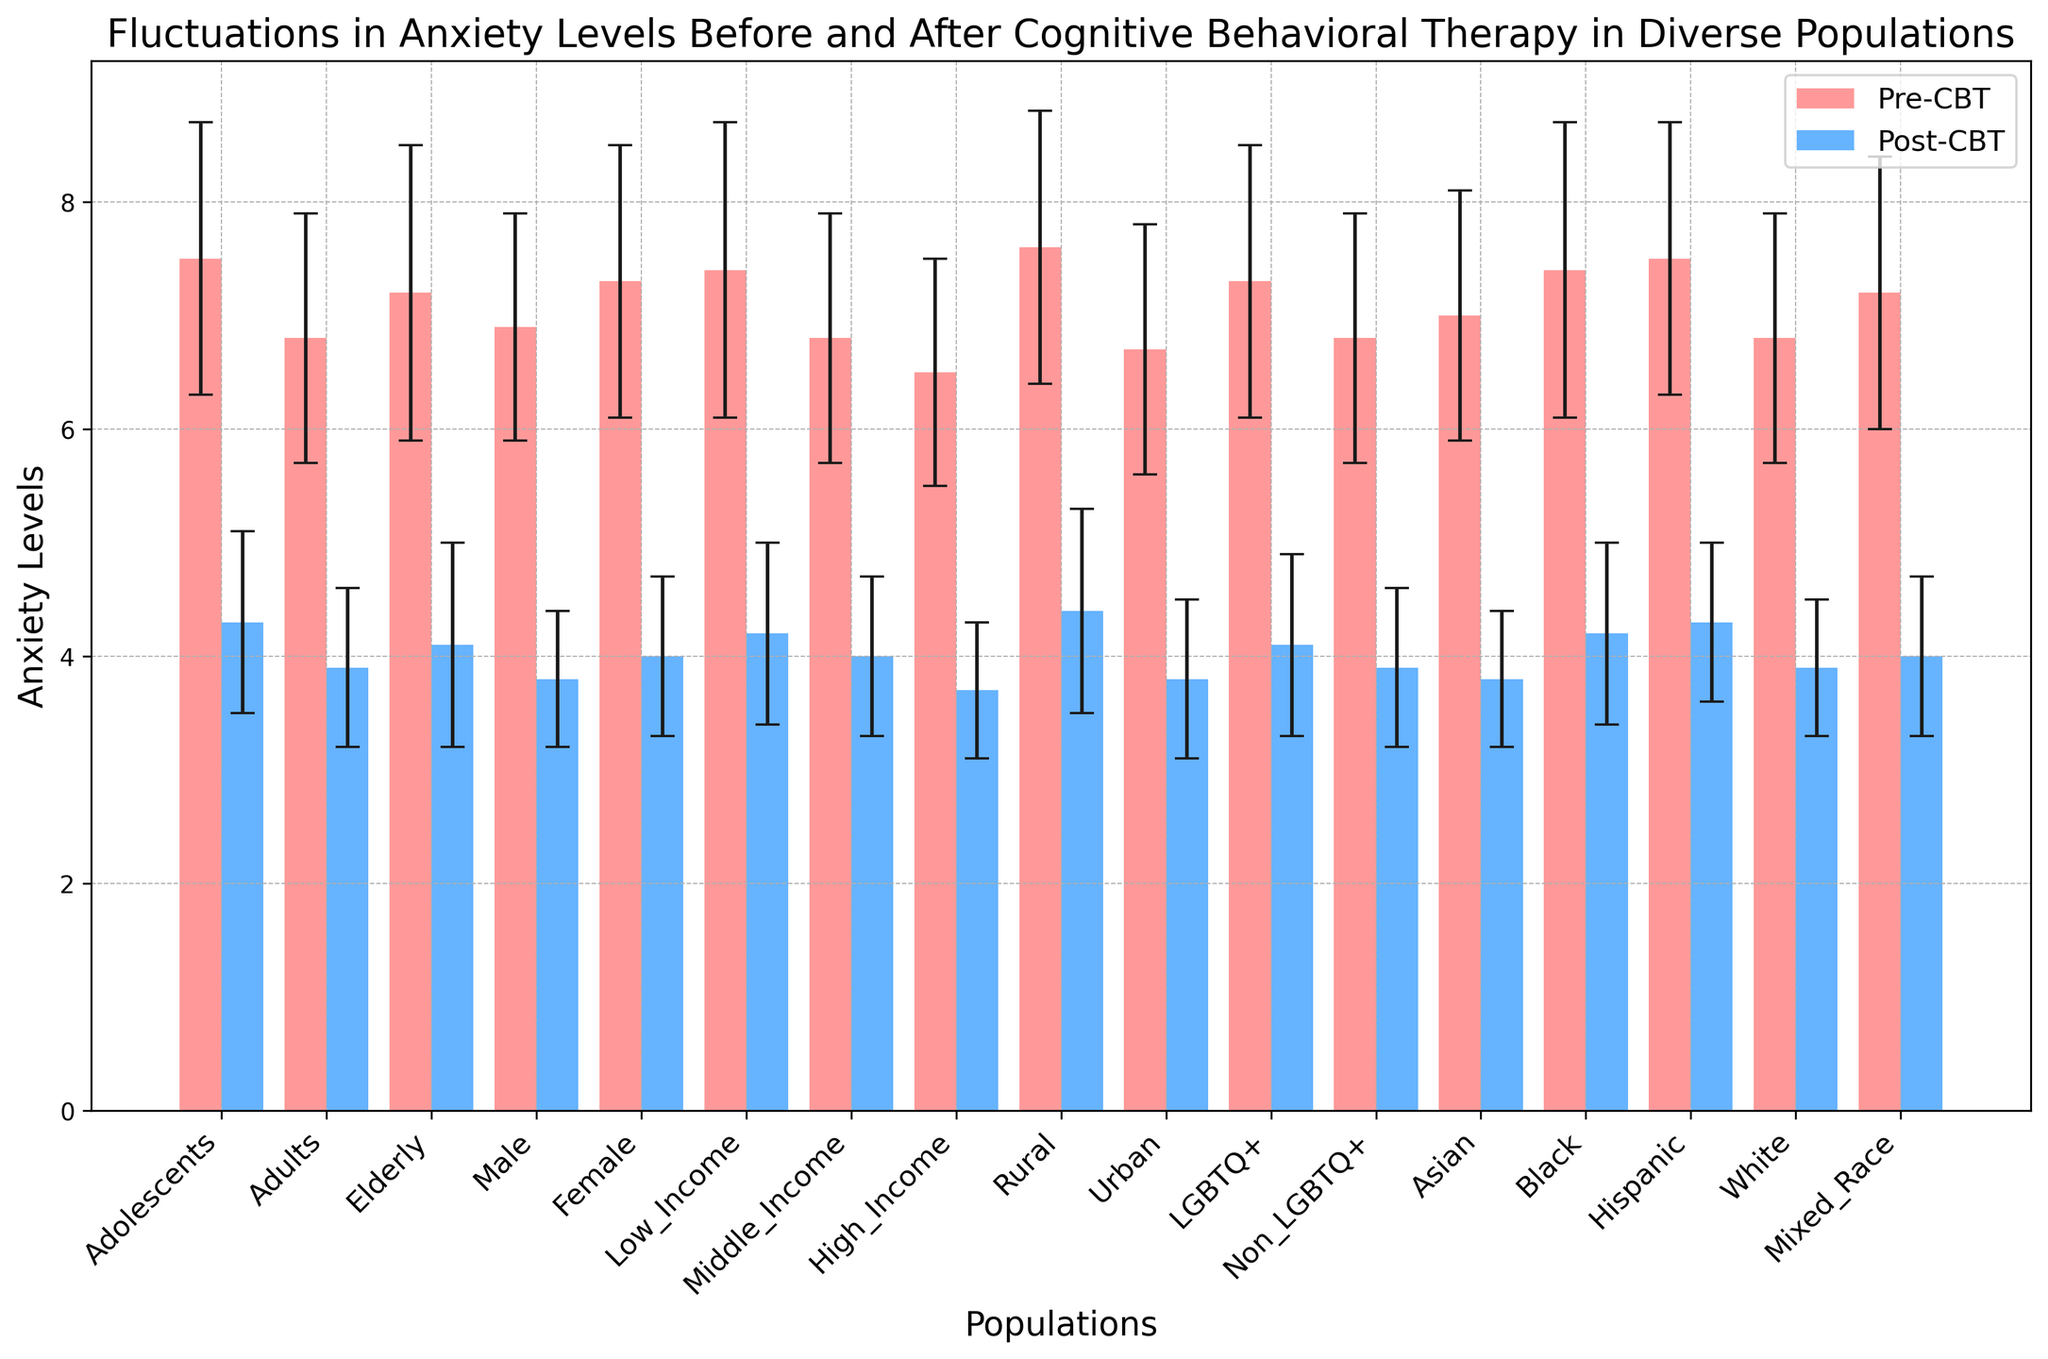Which population shows the largest decrease in anxiety levels after CBT? To find the largest decrease, subtract the post-CBT mean from the pre-CBT mean for each population. Adolescents (3.2), Adults (2.9), Elderly (3.1), Male (3.1), Female (3.3), Low_Income (3.2), Middle_Income (2.8), High_Income (2.8), Rural (3.2), Urban (2.9), LGBTQ+ (3.2), Non_LGBTQ+ (2.9), Asian (3.2), Black (3.2), Hispanic (3.2), White (2.9), Mixed_Race (3.2). The Female group has the largest decrease (3.3).
Answer: Female Which population had the highest pre-CBT anxiety level? Check the pre-CBT mean values for all populations and identify the highest one. Adolescents (7.5), Adults (6.8), Elderly (7.2), Male (6.9), Female (7.3), Low_Income (7.4), Middle_Income (6.8), High_Income (6.5), Rural (7.6), Urban (6.7), LGBTQ+ (7.3), Non_LGBTQ+ (6.8), Asian (7.0), Black (7.4), Hispanic (7.5), White (6.8), Mixed_Race (7.2). Rural has the highest with 7.6.
Answer: Rural For which population is the reduction in anxiety smallest after CBT? Calculate the difference between pre and post-CBT means to find the smallest reduction: Adolescents (3.2), Adults (2.9), Elderly (3.1), Male (3.1), Female (3.3), Low_Income (3.2), Middle_Income (2.8), High_Income (2.8), Rural (3.2), Urban (2.9), LGBTQ+ (3.2), Non_LGBTQ+ (2.9), Asian (3.2), Black (3.2), Hispanic (3.2), White (2.9), Mixed_Race (3.2). The smallest reductions are seen in Middle_Income, High_Income, and White groups, each with a reduction of 2.8 points.
Answer: Middle_Income, High_Income, White Between which two populations is the post-CBT anxiety level most similar? Compare the post-CBT mean anxiety levels to find the most similar values: Adolescents (4.3), Adults (3.9), Elderly (4.1), Male (3.8), Female (4.0), Low_Income (4.2), Middle_Income (4.0), High_Income (3.7), Rural (4.4), Urban (3.8), LGBTQ+ (4.1), Non_LGBTQ+ (3.9), Asian (3.8), Black (4.2), Hispanic (4.3), White (3.9), Mixed_Race (4.0). Mixed_Race and Female both have the value 4.0
Answer: Mixed_Race and Female What is the overall average anxiety level across all populations before CBT? Calculate the average of the pre-CBT means across all populations: (7.5+6.8+7.2+6.9+7.3+7.4+6.8+6.5+7.6+6.7+7.3+6.8+7.0+7.4+7.5+6.8+7.2) / 17 ≈ 7.07
Answer: 7.07 